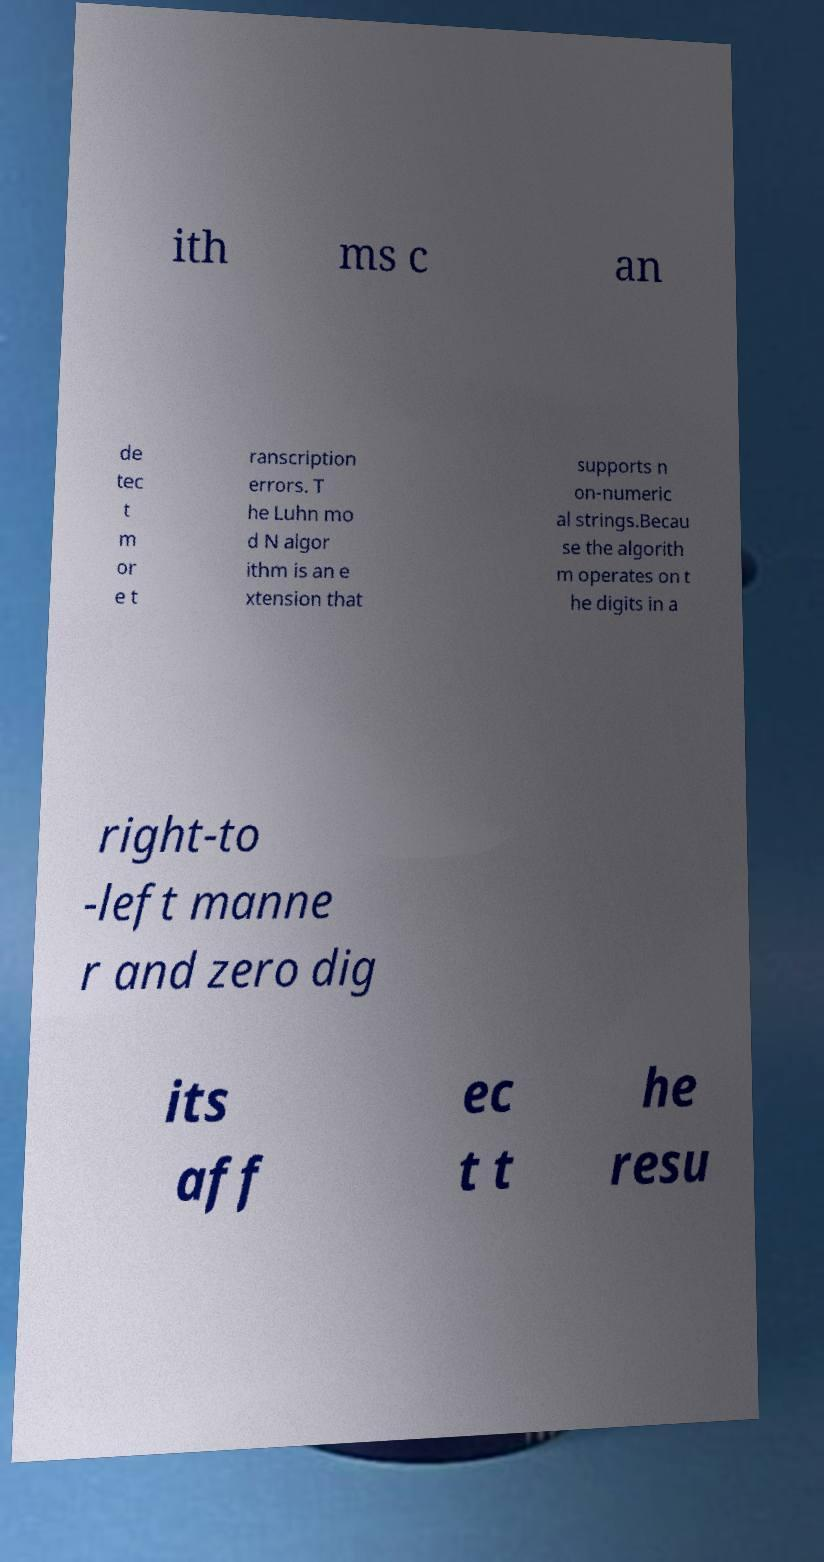What messages or text are displayed in this image? I need them in a readable, typed format. ith ms c an de tec t m or e t ranscription errors. T he Luhn mo d N algor ithm is an e xtension that supports n on-numeric al strings.Becau se the algorith m operates on t he digits in a right-to -left manne r and zero dig its aff ec t t he resu 